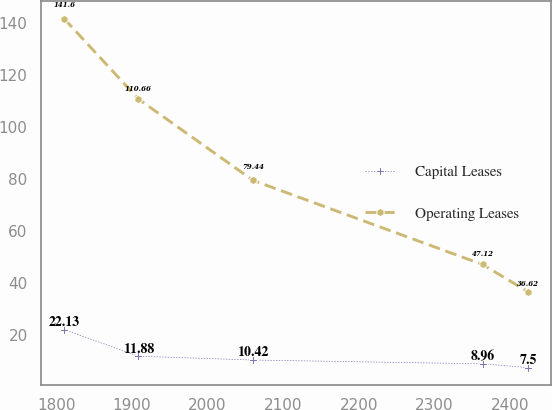Convert chart. <chart><loc_0><loc_0><loc_500><loc_500><line_chart><ecel><fcel>Capital Leases<fcel>Operating Leases<nl><fcel>1809.88<fcel>22.13<fcel>141.6<nl><fcel>1908.42<fcel>11.88<fcel>110.66<nl><fcel>2060.09<fcel>10.42<fcel>79.44<nl><fcel>2363.94<fcel>8.96<fcel>47.12<nl><fcel>2424.45<fcel>7.5<fcel>36.62<nl></chart> 